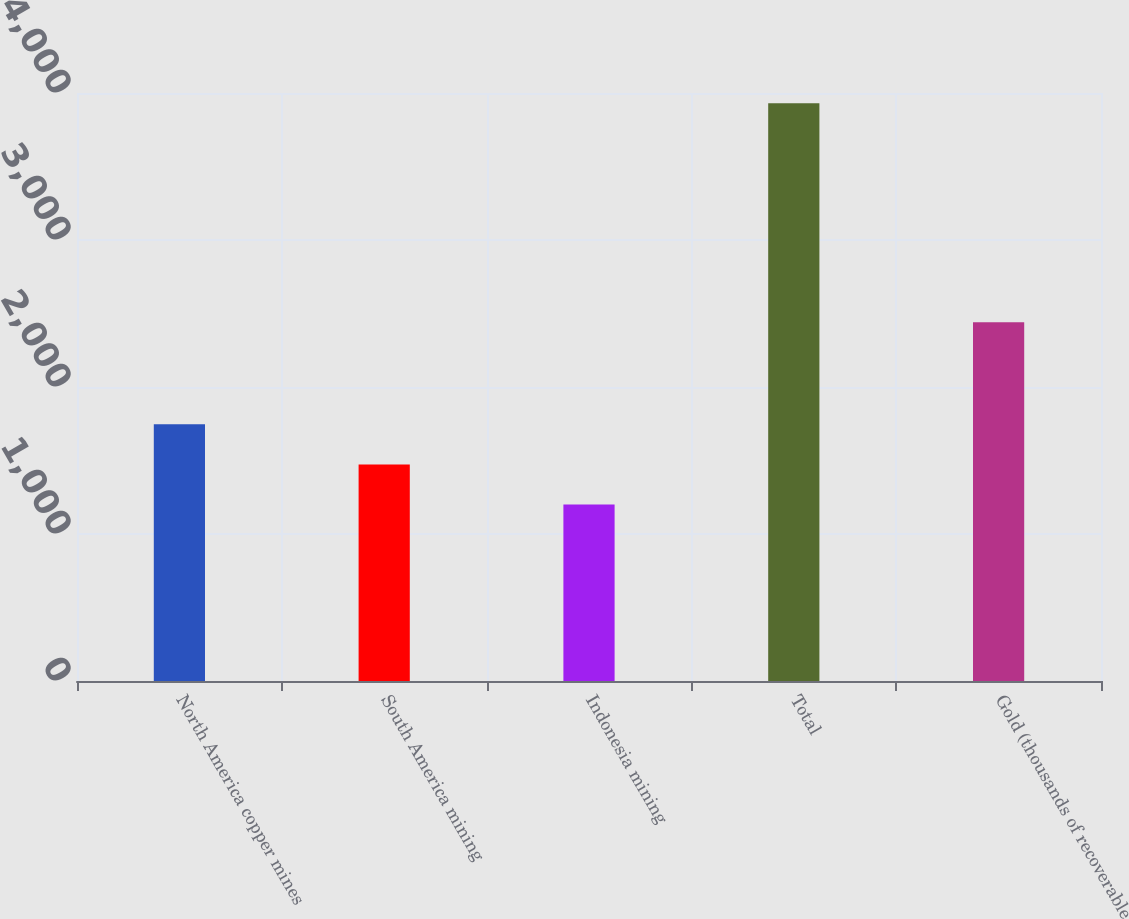Convert chart to OTSL. <chart><loc_0><loc_0><loc_500><loc_500><bar_chart><fcel>North America copper mines<fcel>South America mining<fcel>Indonesia mining<fcel>Total<fcel>Gold (thousands of recoverable<nl><fcel>1746<fcel>1473<fcel>1200<fcel>3930<fcel>2440<nl></chart> 